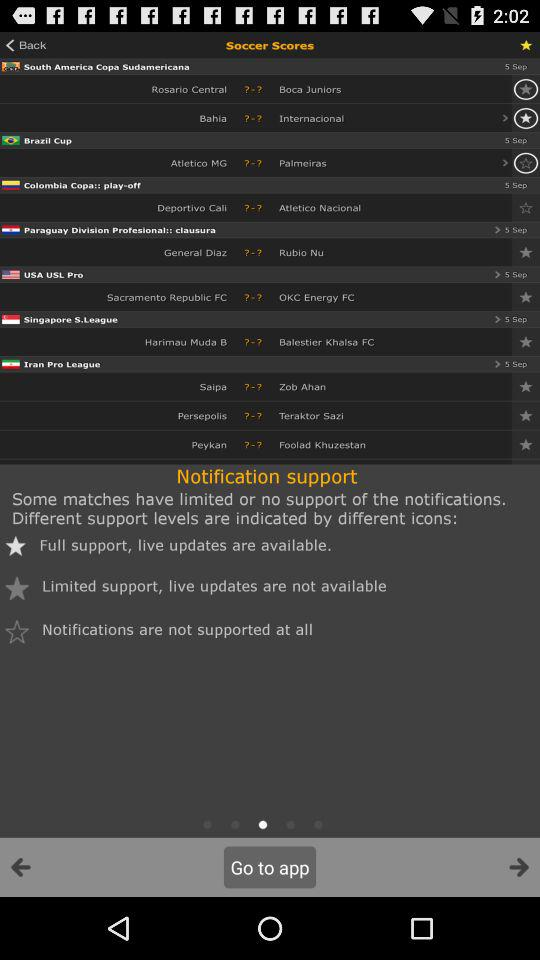Which team will play the match in "Singapore S.League"? The match will be played between "Harimau Muda B" and "Balestier Khalsa FC". 